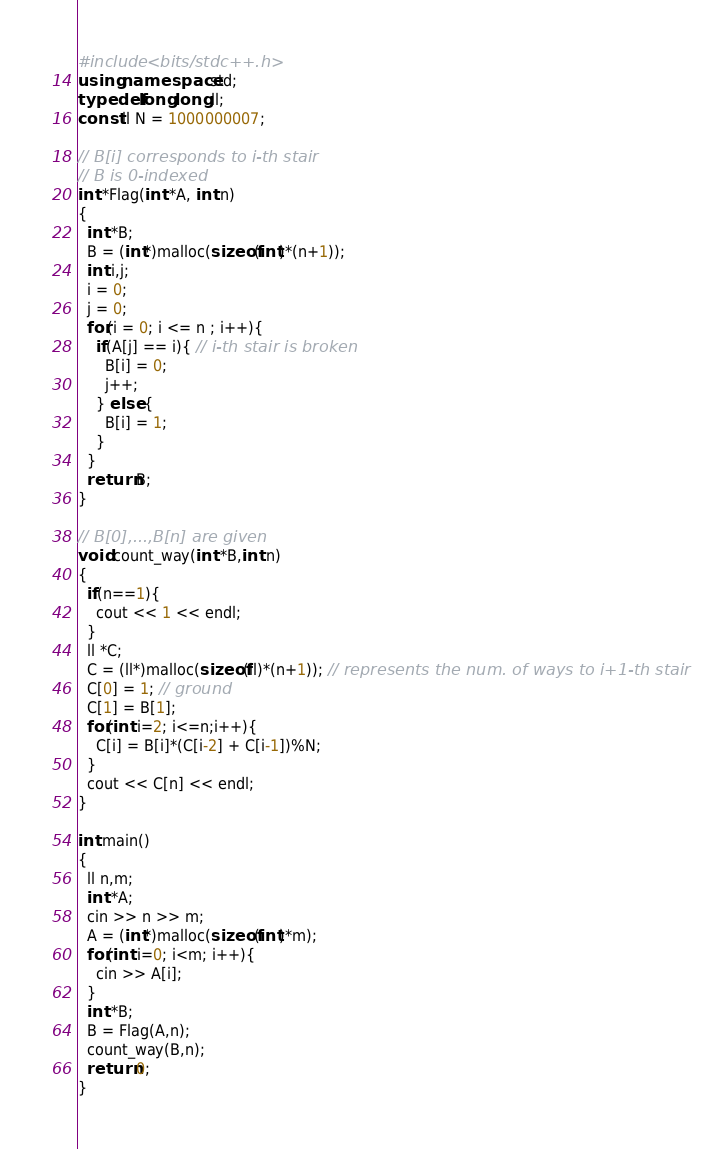Convert code to text. <code><loc_0><loc_0><loc_500><loc_500><_C++_>#include <bits/stdc++.h>
using namespace std;
typedef long long ll;
const ll N = 1000000007;

// B[i] corresponds to i-th stair
// B is 0-indexed
int *Flag(int *A, int n)
{
  int *B;
  B = (int*)malloc(sizeof(int)*(n+1));
  int i,j;
  i = 0;
  j = 0;
  for(i = 0; i <= n ; i++){
    if(A[j] == i){ // i-th stair is broken
      B[i] = 0;
      j++;
    } else {
      B[i] = 1;
    }
  }
  return B;
}

// B[0],...,B[n] are given
void count_way(int *B,int n)
{
  if(n==1){
    cout << 1 << endl;
  }
  ll *C;
  C = (ll*)malloc(sizeof(ll)*(n+1)); // represents the num. of ways to i+1-th stair
  C[0] = 1; // ground
  C[1] = B[1];
  for(int i=2; i<=n;i++){
    C[i] = B[i]*(C[i-2] + C[i-1])%N;
  }
  cout << C[n] << endl;
}

int main()
{
  ll n,m;
  int *A;
  cin >> n >> m;
  A = (int*)malloc(sizeof(int)*m);
  for(int i=0; i<m; i++){
    cin >> A[i];
  }
  int *B;
  B = Flag(A,n);
  count_way(B,n);
  return 0;
}
</code> 